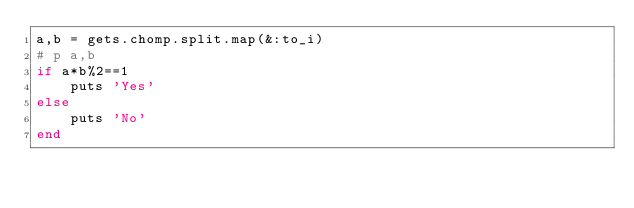<code> <loc_0><loc_0><loc_500><loc_500><_Ruby_>a,b = gets.chomp.split.map(&:to_i)
# p a,b
if a*b%2==1
    puts 'Yes'
else
    puts 'No'
end</code> 